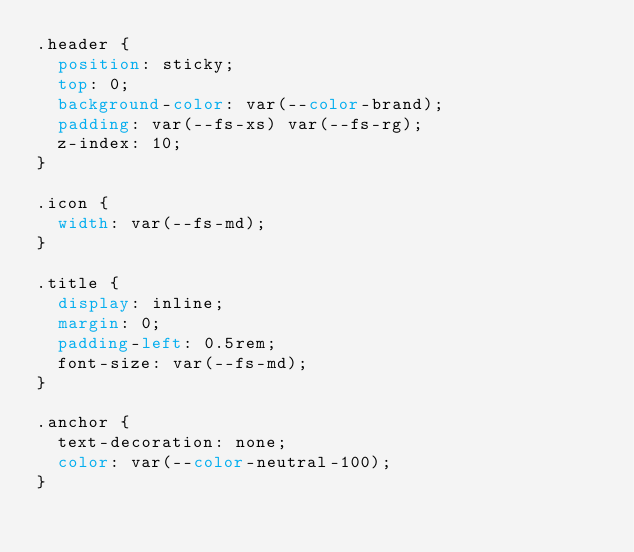<code> <loc_0><loc_0><loc_500><loc_500><_CSS_>.header {
  position: sticky;
  top: 0;
  background-color: var(--color-brand);
  padding: var(--fs-xs) var(--fs-rg);
  z-index: 10;
}

.icon {
  width: var(--fs-md);
}

.title {
  display: inline;
  margin: 0;
  padding-left: 0.5rem;
  font-size: var(--fs-md);
}

.anchor {
  text-decoration: none;
  color: var(--color-neutral-100);
}
</code> 